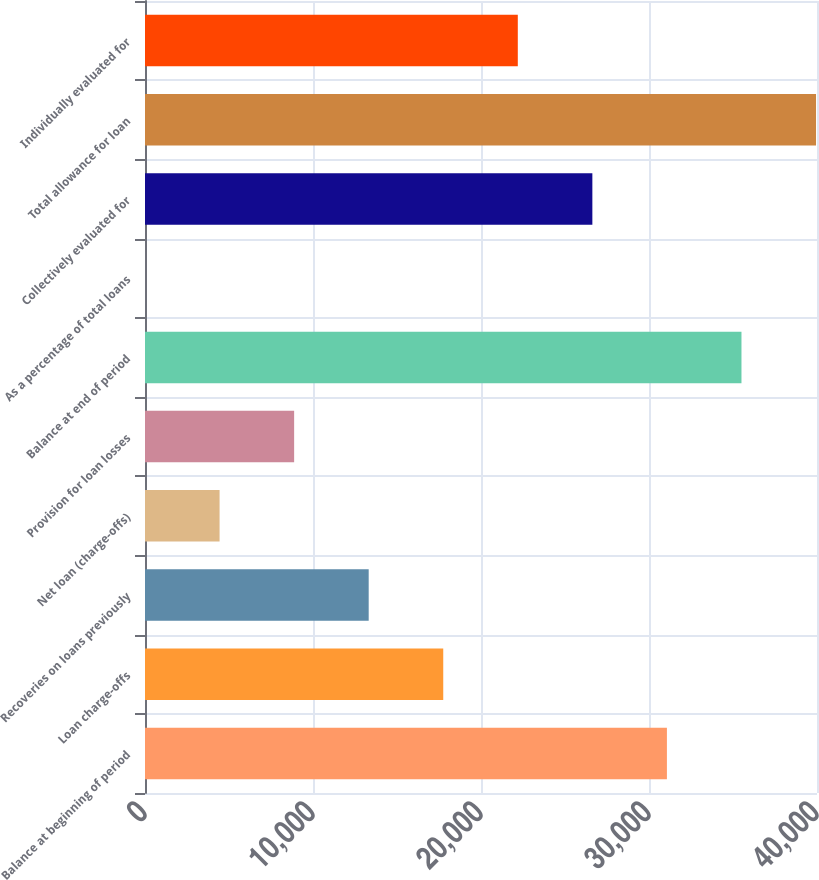Convert chart. <chart><loc_0><loc_0><loc_500><loc_500><bar_chart><fcel>Balance at beginning of period<fcel>Loan charge-offs<fcel>Recoveries on loans previously<fcel>Net loan (charge-offs)<fcel>Provision for loan losses<fcel>Balance at end of period<fcel>As a percentage of total loans<fcel>Collectively evaluated for<fcel>Total allowance for loan<fcel>Individually evaluated for<nl><fcel>31066.4<fcel>17752.7<fcel>13314.8<fcel>4439.08<fcel>8876.96<fcel>35504.2<fcel>1.2<fcel>26628.5<fcel>39942.1<fcel>22190.6<nl></chart> 